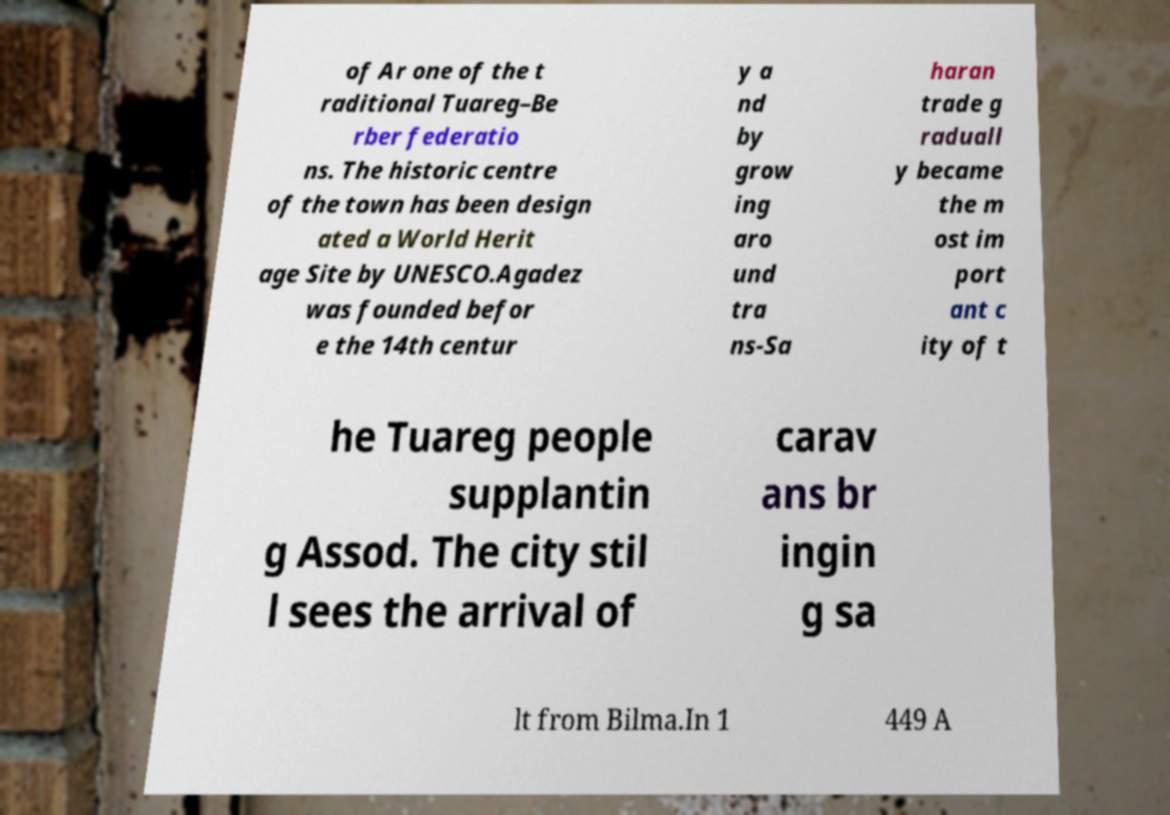I need the written content from this picture converted into text. Can you do that? of Ar one of the t raditional Tuareg–Be rber federatio ns. The historic centre of the town has been design ated a World Herit age Site by UNESCO.Agadez was founded befor e the 14th centur y a nd by grow ing aro und tra ns-Sa haran trade g raduall y became the m ost im port ant c ity of t he Tuareg people supplantin g Assod. The city stil l sees the arrival of carav ans br ingin g sa lt from Bilma.In 1 449 A 